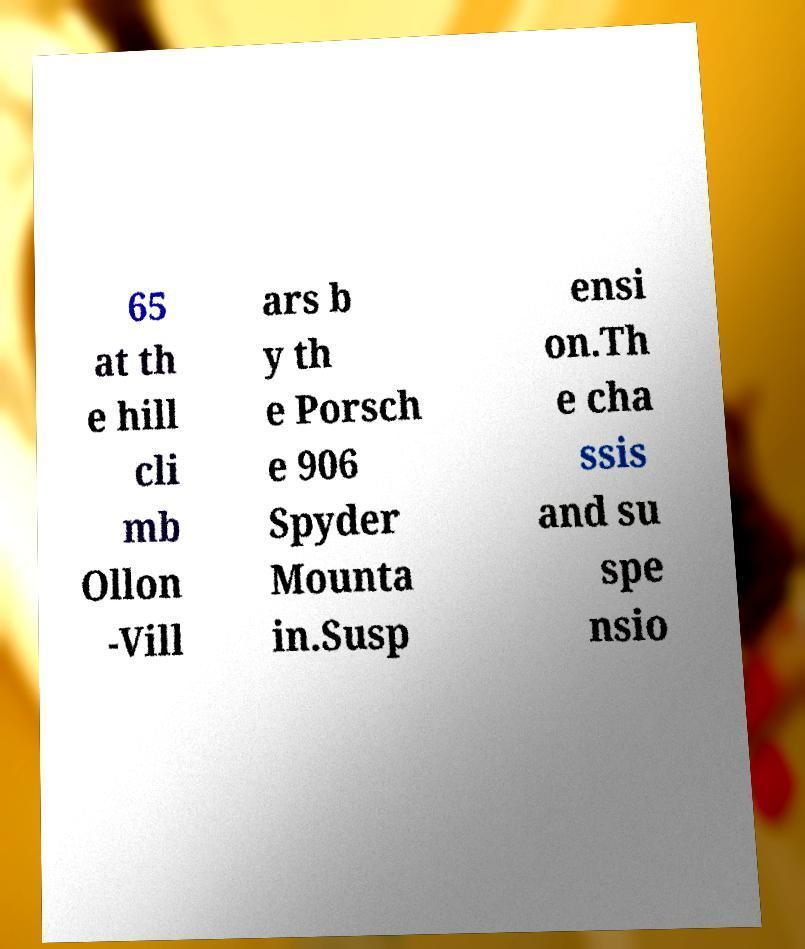I need the written content from this picture converted into text. Can you do that? 65 at th e hill cli mb Ollon -Vill ars b y th e Porsch e 906 Spyder Mounta in.Susp ensi on.Th e cha ssis and su spe nsio 